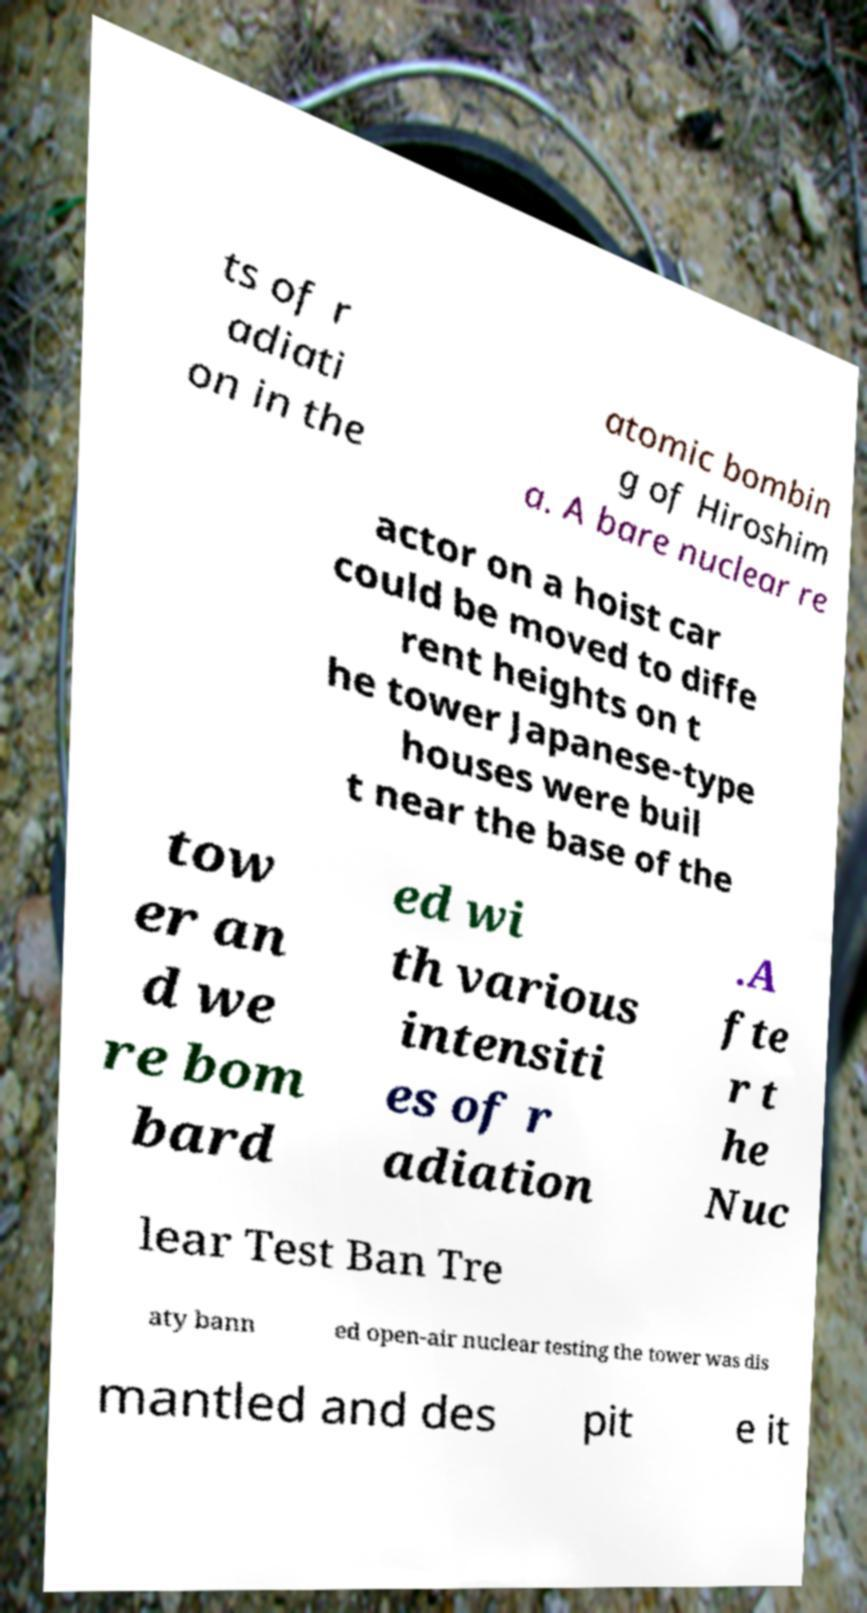Please identify and transcribe the text found in this image. ts of r adiati on in the atomic bombin g of Hiroshim a. A bare nuclear re actor on a hoist car could be moved to diffe rent heights on t he tower Japanese-type houses were buil t near the base of the tow er an d we re bom bard ed wi th various intensiti es of r adiation .A fte r t he Nuc lear Test Ban Tre aty bann ed open-air nuclear testing the tower was dis mantled and des pit e it 